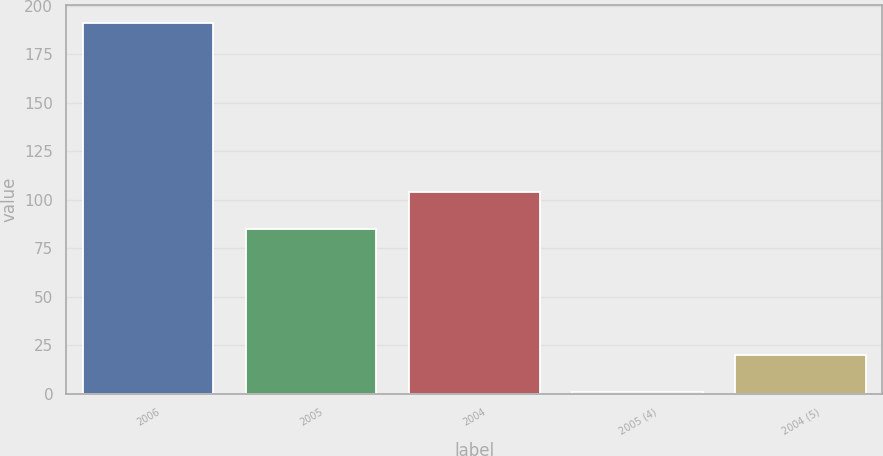Convert chart. <chart><loc_0><loc_0><loc_500><loc_500><bar_chart><fcel>2006<fcel>2005<fcel>2004<fcel>2005 (4)<fcel>2004 (5)<nl><fcel>191<fcel>85<fcel>104<fcel>1<fcel>20<nl></chart> 